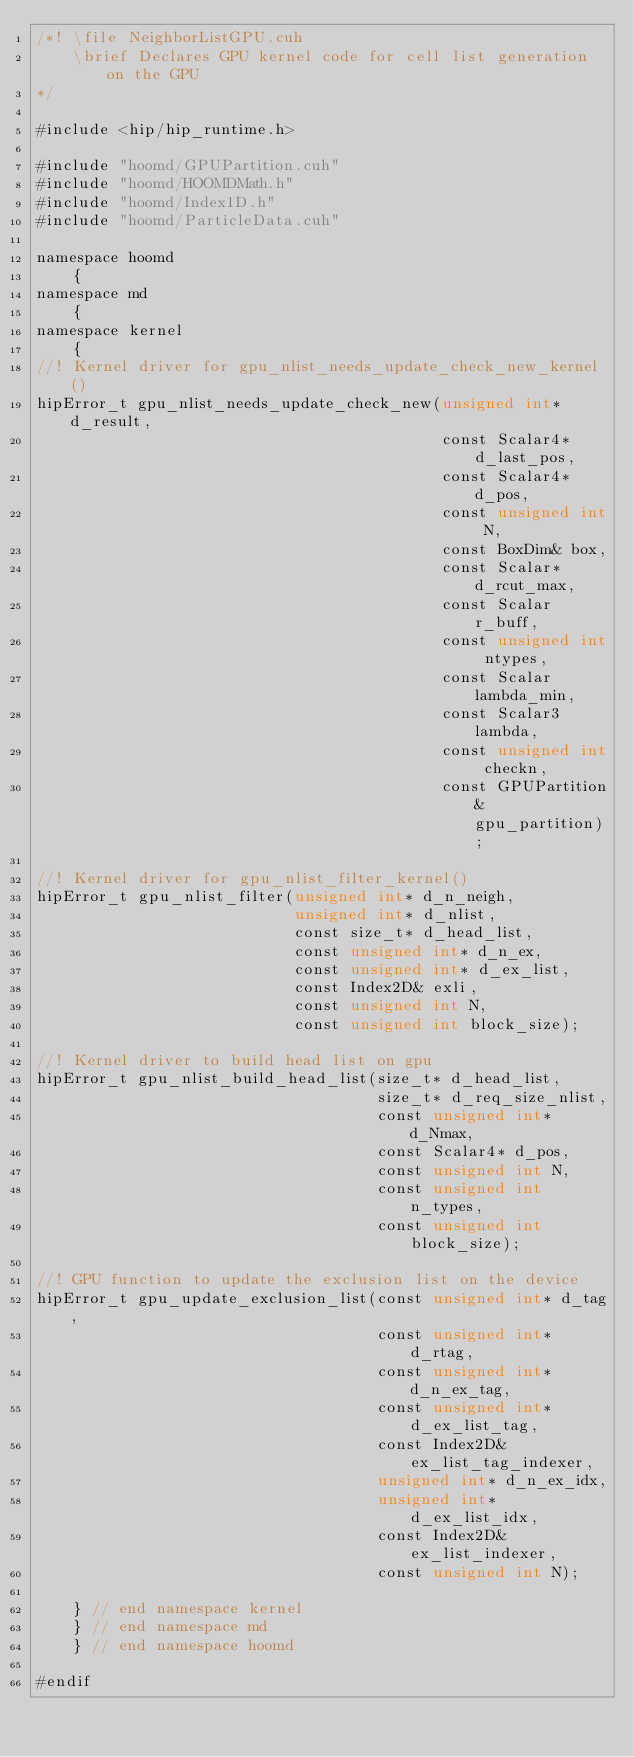<code> <loc_0><loc_0><loc_500><loc_500><_Cuda_>/*! \file NeighborListGPU.cuh
    \brief Declares GPU kernel code for cell list generation on the GPU
*/

#include <hip/hip_runtime.h>

#include "hoomd/GPUPartition.cuh"
#include "hoomd/HOOMDMath.h"
#include "hoomd/Index1D.h"
#include "hoomd/ParticleData.cuh"

namespace hoomd
    {
namespace md
    {
namespace kernel
    {
//! Kernel driver for gpu_nlist_needs_update_check_new_kernel()
hipError_t gpu_nlist_needs_update_check_new(unsigned int* d_result,
                                            const Scalar4* d_last_pos,
                                            const Scalar4* d_pos,
                                            const unsigned int N,
                                            const BoxDim& box,
                                            const Scalar* d_rcut_max,
                                            const Scalar r_buff,
                                            const unsigned int ntypes,
                                            const Scalar lambda_min,
                                            const Scalar3 lambda,
                                            const unsigned int checkn,
                                            const GPUPartition& gpu_partition);

//! Kernel driver for gpu_nlist_filter_kernel()
hipError_t gpu_nlist_filter(unsigned int* d_n_neigh,
                            unsigned int* d_nlist,
                            const size_t* d_head_list,
                            const unsigned int* d_n_ex,
                            const unsigned int* d_ex_list,
                            const Index2D& exli,
                            const unsigned int N,
                            const unsigned int block_size);

//! Kernel driver to build head list on gpu
hipError_t gpu_nlist_build_head_list(size_t* d_head_list,
                                     size_t* d_req_size_nlist,
                                     const unsigned int* d_Nmax,
                                     const Scalar4* d_pos,
                                     const unsigned int N,
                                     const unsigned int n_types,
                                     const unsigned int block_size);

//! GPU function to update the exclusion list on the device
hipError_t gpu_update_exclusion_list(const unsigned int* d_tag,
                                     const unsigned int* d_rtag,
                                     const unsigned int* d_n_ex_tag,
                                     const unsigned int* d_ex_list_tag,
                                     const Index2D& ex_list_tag_indexer,
                                     unsigned int* d_n_ex_idx,
                                     unsigned int* d_ex_list_idx,
                                     const Index2D& ex_list_indexer,
                                     const unsigned int N);

    } // end namespace kernel
    } // end namespace md
    } // end namespace hoomd

#endif
</code> 